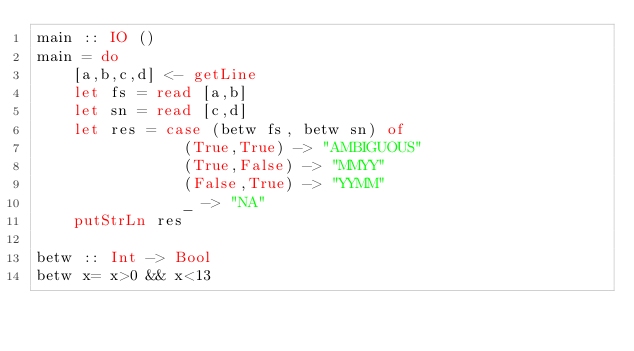<code> <loc_0><loc_0><loc_500><loc_500><_Haskell_>main :: IO ()
main = do
    [a,b,c,d] <- getLine
    let fs = read [a,b]
    let sn = read [c,d]
    let res = case (betw fs, betw sn) of
                (True,True) -> "AMBIGUOUS"
                (True,False) -> "MMYY"
                (False,True) -> "YYMM"
                _ -> "NA"
    putStrLn res

betw :: Int -> Bool 
betw x= x>0 && x<13

</code> 